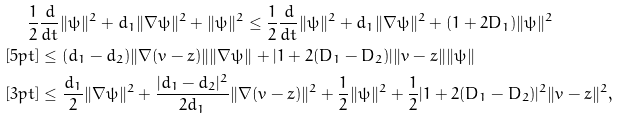<formula> <loc_0><loc_0><loc_500><loc_500>\frac { 1 } { 2 } & \frac { d } { d t } \| \psi \| ^ { 2 } + d _ { 1 } \| \nabla \psi \| ^ { 2 } + \| \psi \| ^ { 2 } \leq \frac { 1 } { 2 } \frac { d } { d t } \| \psi \| ^ { 2 } + d _ { 1 } \| \nabla \psi \| ^ { 2 } + ( 1 + 2 D _ { 1 } ) \| \psi \| ^ { 2 } \\ [ 5 p t ] & \leq ( d _ { 1 } - d _ { 2 } ) \| \nabla ( v - z ) \| \| \nabla \psi \| + | 1 + 2 ( D _ { 1 } - D _ { 2 } ) | \| v - z \| \| \psi \| \\ [ 3 p t ] & \leq \frac { d _ { 1 } } { 2 } \| \nabla \psi \| ^ { 2 } + \frac { | d _ { 1 } - d _ { 2 } | ^ { 2 } } { 2 d _ { 1 } } \| \nabla ( v - z ) \| ^ { 2 } + \frac { 1 } { 2 } \| \psi \| ^ { 2 } + \frac { 1 } { 2 } | 1 + 2 ( D _ { 1 } - D _ { 2 } ) | ^ { 2 } \| v - z \| ^ { 2 } ,</formula> 